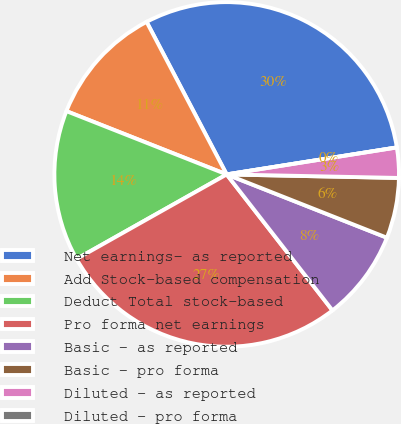<chart> <loc_0><loc_0><loc_500><loc_500><pie_chart><fcel>Net earnings- as reported<fcel>Add Stock-based compensation<fcel>Deduct Total stock-based<fcel>Pro forma net earnings<fcel>Basic - as reported<fcel>Basic - pro forma<fcel>Diluted - as reported<fcel>Diluted - pro forma<nl><fcel>30.19%<fcel>11.32%<fcel>14.15%<fcel>27.36%<fcel>8.49%<fcel>5.66%<fcel>2.83%<fcel>0.0%<nl></chart> 